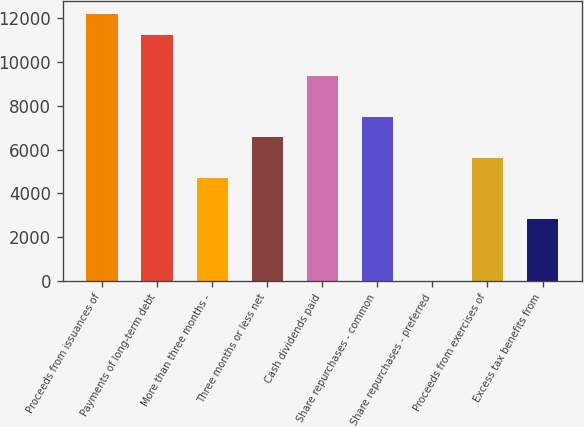Convert chart to OTSL. <chart><loc_0><loc_0><loc_500><loc_500><bar_chart><fcel>Proceeds from issuances of<fcel>Payments of long-term debt<fcel>More than three months -<fcel>Three months or less net<fcel>Cash dividends paid<fcel>Share repurchases - common<fcel>Share repurchases - preferred<fcel>Proceeds from exercises of<fcel>Excess tax benefits from<nl><fcel>12185.4<fcel>11248.6<fcel>4691<fcel>6564.6<fcel>9375<fcel>7501.4<fcel>7<fcel>5627.8<fcel>2817.4<nl></chart> 